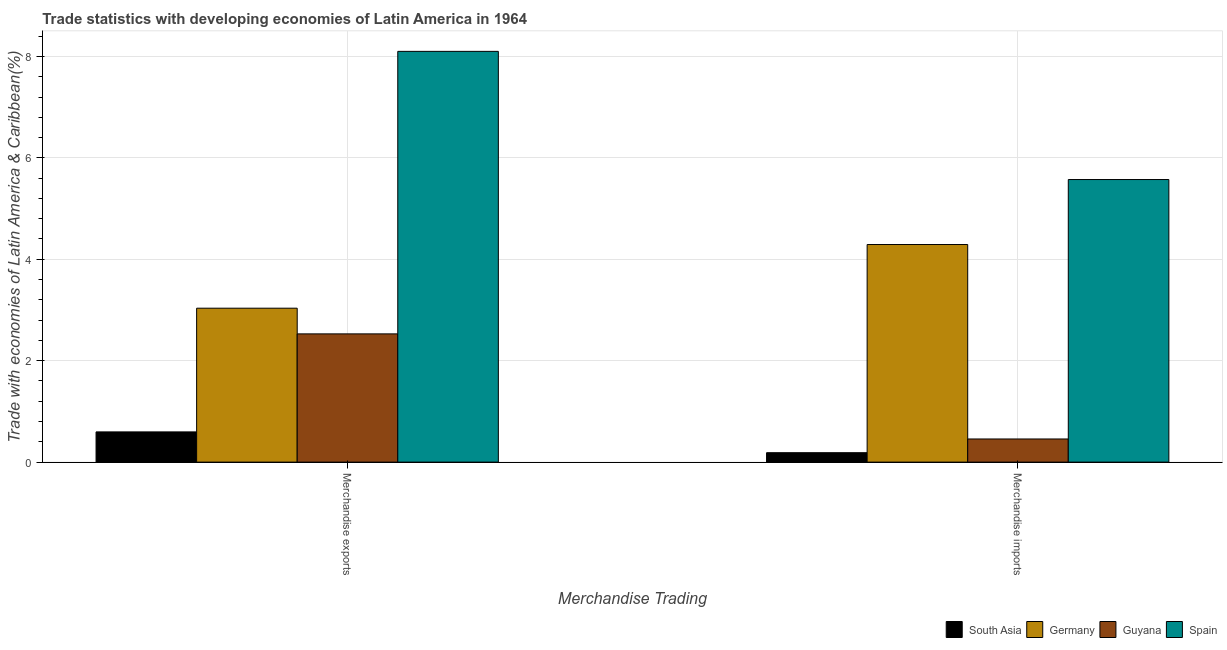How many groups of bars are there?
Keep it short and to the point. 2. Are the number of bars on each tick of the X-axis equal?
Ensure brevity in your answer.  Yes. What is the label of the 2nd group of bars from the left?
Make the answer very short. Merchandise imports. What is the merchandise imports in Guyana?
Ensure brevity in your answer.  0.46. Across all countries, what is the maximum merchandise imports?
Offer a very short reply. 5.57. Across all countries, what is the minimum merchandise exports?
Offer a very short reply. 0.6. What is the total merchandise imports in the graph?
Ensure brevity in your answer.  10.51. What is the difference between the merchandise exports in Germany and that in Spain?
Provide a short and direct response. -5.06. What is the difference between the merchandise exports in Guyana and the merchandise imports in South Asia?
Keep it short and to the point. 2.34. What is the average merchandise imports per country?
Provide a short and direct response. 2.63. What is the difference between the merchandise imports and merchandise exports in South Asia?
Provide a short and direct response. -0.41. What is the ratio of the merchandise imports in Germany to that in South Asia?
Provide a short and direct response. 23.09. Is the merchandise imports in South Asia less than that in Spain?
Your answer should be compact. Yes. In how many countries, is the merchandise exports greater than the average merchandise exports taken over all countries?
Offer a very short reply. 1. How many bars are there?
Your answer should be very brief. 8. What is the difference between two consecutive major ticks on the Y-axis?
Your response must be concise. 2. Are the values on the major ticks of Y-axis written in scientific E-notation?
Provide a short and direct response. No. Where does the legend appear in the graph?
Your answer should be compact. Bottom right. How many legend labels are there?
Give a very brief answer. 4. What is the title of the graph?
Your response must be concise. Trade statistics with developing economies of Latin America in 1964. What is the label or title of the X-axis?
Provide a short and direct response. Merchandise Trading. What is the label or title of the Y-axis?
Your answer should be compact. Trade with economies of Latin America & Caribbean(%). What is the Trade with economies of Latin America & Caribbean(%) in South Asia in Merchandise exports?
Your answer should be compact. 0.6. What is the Trade with economies of Latin America & Caribbean(%) in Germany in Merchandise exports?
Keep it short and to the point. 3.04. What is the Trade with economies of Latin America & Caribbean(%) in Guyana in Merchandise exports?
Offer a terse response. 2.53. What is the Trade with economies of Latin America & Caribbean(%) in Spain in Merchandise exports?
Offer a terse response. 8.1. What is the Trade with economies of Latin America & Caribbean(%) in South Asia in Merchandise imports?
Offer a very short reply. 0.19. What is the Trade with economies of Latin America & Caribbean(%) of Germany in Merchandise imports?
Give a very brief answer. 4.29. What is the Trade with economies of Latin America & Caribbean(%) of Guyana in Merchandise imports?
Ensure brevity in your answer.  0.46. What is the Trade with economies of Latin America & Caribbean(%) in Spain in Merchandise imports?
Your response must be concise. 5.57. Across all Merchandise Trading, what is the maximum Trade with economies of Latin America & Caribbean(%) in South Asia?
Your answer should be very brief. 0.6. Across all Merchandise Trading, what is the maximum Trade with economies of Latin America & Caribbean(%) in Germany?
Ensure brevity in your answer.  4.29. Across all Merchandise Trading, what is the maximum Trade with economies of Latin America & Caribbean(%) in Guyana?
Make the answer very short. 2.53. Across all Merchandise Trading, what is the maximum Trade with economies of Latin America & Caribbean(%) in Spain?
Keep it short and to the point. 8.1. Across all Merchandise Trading, what is the minimum Trade with economies of Latin America & Caribbean(%) of South Asia?
Give a very brief answer. 0.19. Across all Merchandise Trading, what is the minimum Trade with economies of Latin America & Caribbean(%) in Germany?
Your response must be concise. 3.04. Across all Merchandise Trading, what is the minimum Trade with economies of Latin America & Caribbean(%) of Guyana?
Your answer should be compact. 0.46. Across all Merchandise Trading, what is the minimum Trade with economies of Latin America & Caribbean(%) in Spain?
Keep it short and to the point. 5.57. What is the total Trade with economies of Latin America & Caribbean(%) in South Asia in the graph?
Provide a short and direct response. 0.78. What is the total Trade with economies of Latin America & Caribbean(%) in Germany in the graph?
Your answer should be very brief. 7.33. What is the total Trade with economies of Latin America & Caribbean(%) of Guyana in the graph?
Offer a terse response. 2.99. What is the total Trade with economies of Latin America & Caribbean(%) of Spain in the graph?
Give a very brief answer. 13.67. What is the difference between the Trade with economies of Latin America & Caribbean(%) in South Asia in Merchandise exports and that in Merchandise imports?
Make the answer very short. 0.41. What is the difference between the Trade with economies of Latin America & Caribbean(%) in Germany in Merchandise exports and that in Merchandise imports?
Provide a succinct answer. -1.26. What is the difference between the Trade with economies of Latin America & Caribbean(%) of Guyana in Merchandise exports and that in Merchandise imports?
Offer a very short reply. 2.07. What is the difference between the Trade with economies of Latin America & Caribbean(%) in Spain in Merchandise exports and that in Merchandise imports?
Your response must be concise. 2.53. What is the difference between the Trade with economies of Latin America & Caribbean(%) of South Asia in Merchandise exports and the Trade with economies of Latin America & Caribbean(%) of Germany in Merchandise imports?
Offer a very short reply. -3.7. What is the difference between the Trade with economies of Latin America & Caribbean(%) in South Asia in Merchandise exports and the Trade with economies of Latin America & Caribbean(%) in Guyana in Merchandise imports?
Ensure brevity in your answer.  0.14. What is the difference between the Trade with economies of Latin America & Caribbean(%) in South Asia in Merchandise exports and the Trade with economies of Latin America & Caribbean(%) in Spain in Merchandise imports?
Provide a succinct answer. -4.98. What is the difference between the Trade with economies of Latin America & Caribbean(%) in Germany in Merchandise exports and the Trade with economies of Latin America & Caribbean(%) in Guyana in Merchandise imports?
Give a very brief answer. 2.58. What is the difference between the Trade with economies of Latin America & Caribbean(%) in Germany in Merchandise exports and the Trade with economies of Latin America & Caribbean(%) in Spain in Merchandise imports?
Give a very brief answer. -2.54. What is the difference between the Trade with economies of Latin America & Caribbean(%) in Guyana in Merchandise exports and the Trade with economies of Latin America & Caribbean(%) in Spain in Merchandise imports?
Keep it short and to the point. -3.04. What is the average Trade with economies of Latin America & Caribbean(%) of South Asia per Merchandise Trading?
Give a very brief answer. 0.39. What is the average Trade with economies of Latin America & Caribbean(%) of Germany per Merchandise Trading?
Your answer should be compact. 3.66. What is the average Trade with economies of Latin America & Caribbean(%) in Guyana per Merchandise Trading?
Your answer should be compact. 1.49. What is the average Trade with economies of Latin America & Caribbean(%) of Spain per Merchandise Trading?
Offer a terse response. 6.84. What is the difference between the Trade with economies of Latin America & Caribbean(%) of South Asia and Trade with economies of Latin America & Caribbean(%) of Germany in Merchandise exports?
Keep it short and to the point. -2.44. What is the difference between the Trade with economies of Latin America & Caribbean(%) of South Asia and Trade with economies of Latin America & Caribbean(%) of Guyana in Merchandise exports?
Provide a short and direct response. -1.93. What is the difference between the Trade with economies of Latin America & Caribbean(%) in South Asia and Trade with economies of Latin America & Caribbean(%) in Spain in Merchandise exports?
Make the answer very short. -7.5. What is the difference between the Trade with economies of Latin America & Caribbean(%) of Germany and Trade with economies of Latin America & Caribbean(%) of Guyana in Merchandise exports?
Your answer should be compact. 0.51. What is the difference between the Trade with economies of Latin America & Caribbean(%) in Germany and Trade with economies of Latin America & Caribbean(%) in Spain in Merchandise exports?
Keep it short and to the point. -5.06. What is the difference between the Trade with economies of Latin America & Caribbean(%) of Guyana and Trade with economies of Latin America & Caribbean(%) of Spain in Merchandise exports?
Provide a succinct answer. -5.57. What is the difference between the Trade with economies of Latin America & Caribbean(%) in South Asia and Trade with economies of Latin America & Caribbean(%) in Germany in Merchandise imports?
Provide a short and direct response. -4.11. What is the difference between the Trade with economies of Latin America & Caribbean(%) of South Asia and Trade with economies of Latin America & Caribbean(%) of Guyana in Merchandise imports?
Your response must be concise. -0.27. What is the difference between the Trade with economies of Latin America & Caribbean(%) of South Asia and Trade with economies of Latin America & Caribbean(%) of Spain in Merchandise imports?
Keep it short and to the point. -5.39. What is the difference between the Trade with economies of Latin America & Caribbean(%) of Germany and Trade with economies of Latin America & Caribbean(%) of Guyana in Merchandise imports?
Provide a short and direct response. 3.83. What is the difference between the Trade with economies of Latin America & Caribbean(%) in Germany and Trade with economies of Latin America & Caribbean(%) in Spain in Merchandise imports?
Your response must be concise. -1.28. What is the difference between the Trade with economies of Latin America & Caribbean(%) of Guyana and Trade with economies of Latin America & Caribbean(%) of Spain in Merchandise imports?
Offer a very short reply. -5.12. What is the ratio of the Trade with economies of Latin America & Caribbean(%) in South Asia in Merchandise exports to that in Merchandise imports?
Your answer should be very brief. 3.21. What is the ratio of the Trade with economies of Latin America & Caribbean(%) of Germany in Merchandise exports to that in Merchandise imports?
Provide a succinct answer. 0.71. What is the ratio of the Trade with economies of Latin America & Caribbean(%) in Guyana in Merchandise exports to that in Merchandise imports?
Ensure brevity in your answer.  5.54. What is the ratio of the Trade with economies of Latin America & Caribbean(%) in Spain in Merchandise exports to that in Merchandise imports?
Ensure brevity in your answer.  1.45. What is the difference between the highest and the second highest Trade with economies of Latin America & Caribbean(%) of South Asia?
Give a very brief answer. 0.41. What is the difference between the highest and the second highest Trade with economies of Latin America & Caribbean(%) in Germany?
Make the answer very short. 1.26. What is the difference between the highest and the second highest Trade with economies of Latin America & Caribbean(%) in Guyana?
Your response must be concise. 2.07. What is the difference between the highest and the second highest Trade with economies of Latin America & Caribbean(%) of Spain?
Your answer should be very brief. 2.53. What is the difference between the highest and the lowest Trade with economies of Latin America & Caribbean(%) of South Asia?
Your response must be concise. 0.41. What is the difference between the highest and the lowest Trade with economies of Latin America & Caribbean(%) in Germany?
Provide a short and direct response. 1.26. What is the difference between the highest and the lowest Trade with economies of Latin America & Caribbean(%) in Guyana?
Your answer should be compact. 2.07. What is the difference between the highest and the lowest Trade with economies of Latin America & Caribbean(%) of Spain?
Offer a terse response. 2.53. 